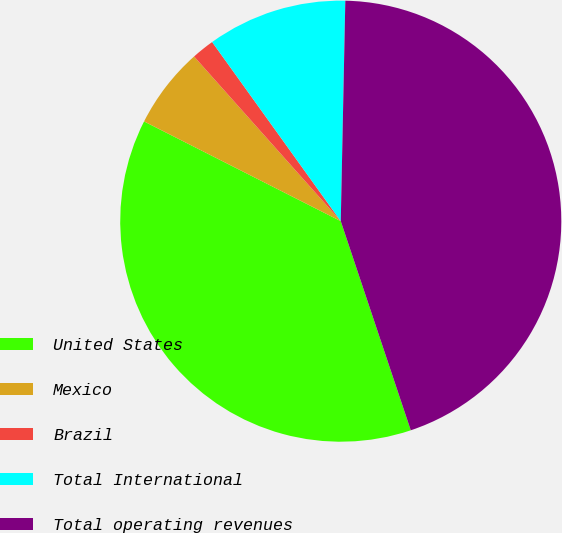Convert chart. <chart><loc_0><loc_0><loc_500><loc_500><pie_chart><fcel>United States<fcel>Mexico<fcel>Brazil<fcel>Total International<fcel>Total operating revenues<nl><fcel>37.61%<fcel>5.95%<fcel>1.67%<fcel>10.24%<fcel>44.53%<nl></chart> 